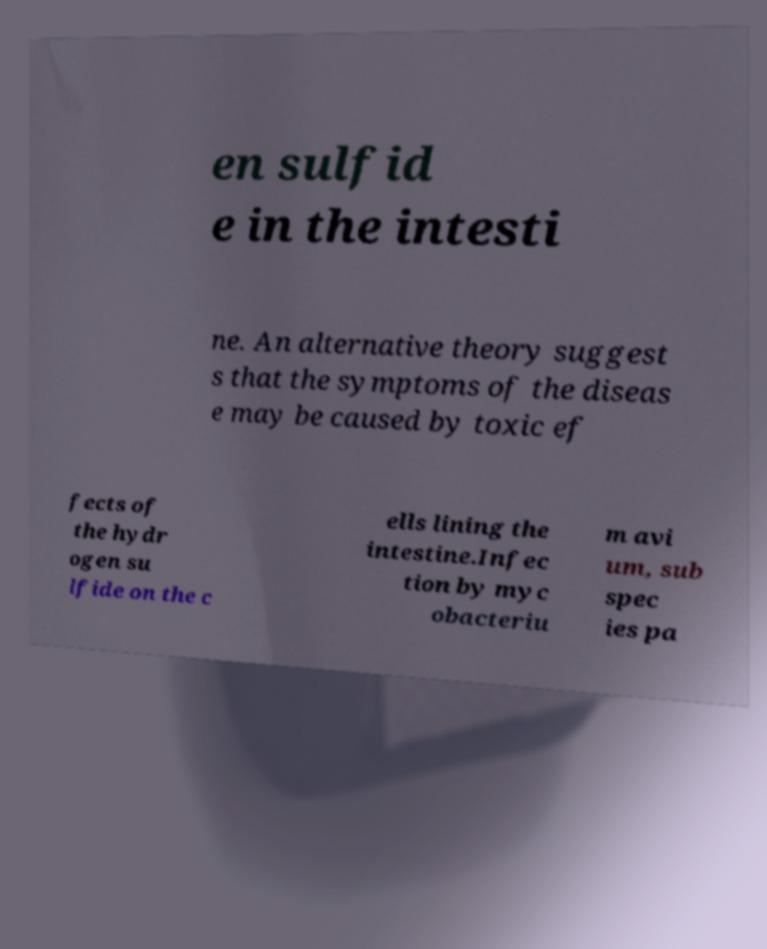I need the written content from this picture converted into text. Can you do that? en sulfid e in the intesti ne. An alternative theory suggest s that the symptoms of the diseas e may be caused by toxic ef fects of the hydr ogen su lfide on the c ells lining the intestine.Infec tion by myc obacteriu m avi um, sub spec ies pa 